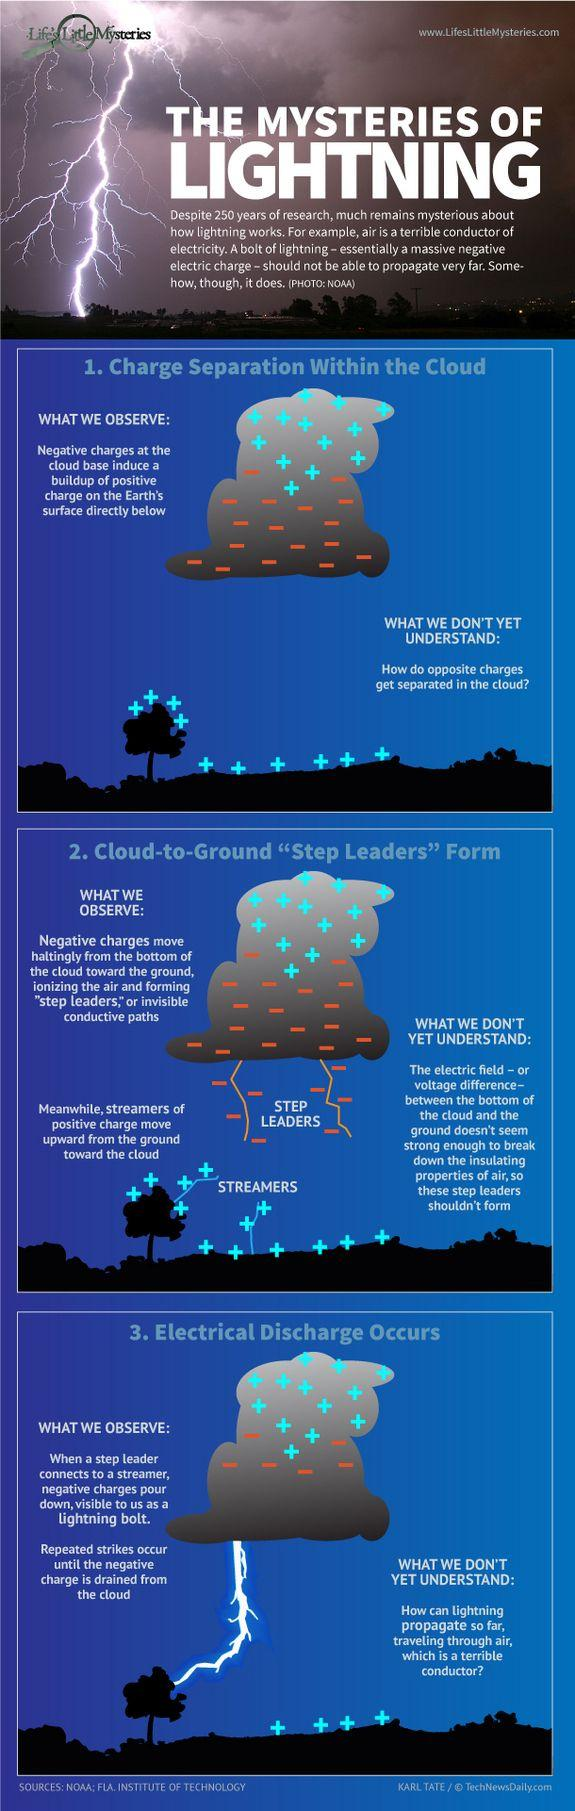Indicate a few pertinent items in this graphic. Cations that move upward towards the sky are referred to as streamers. Step Leaders are anions that move towards the Earth. 